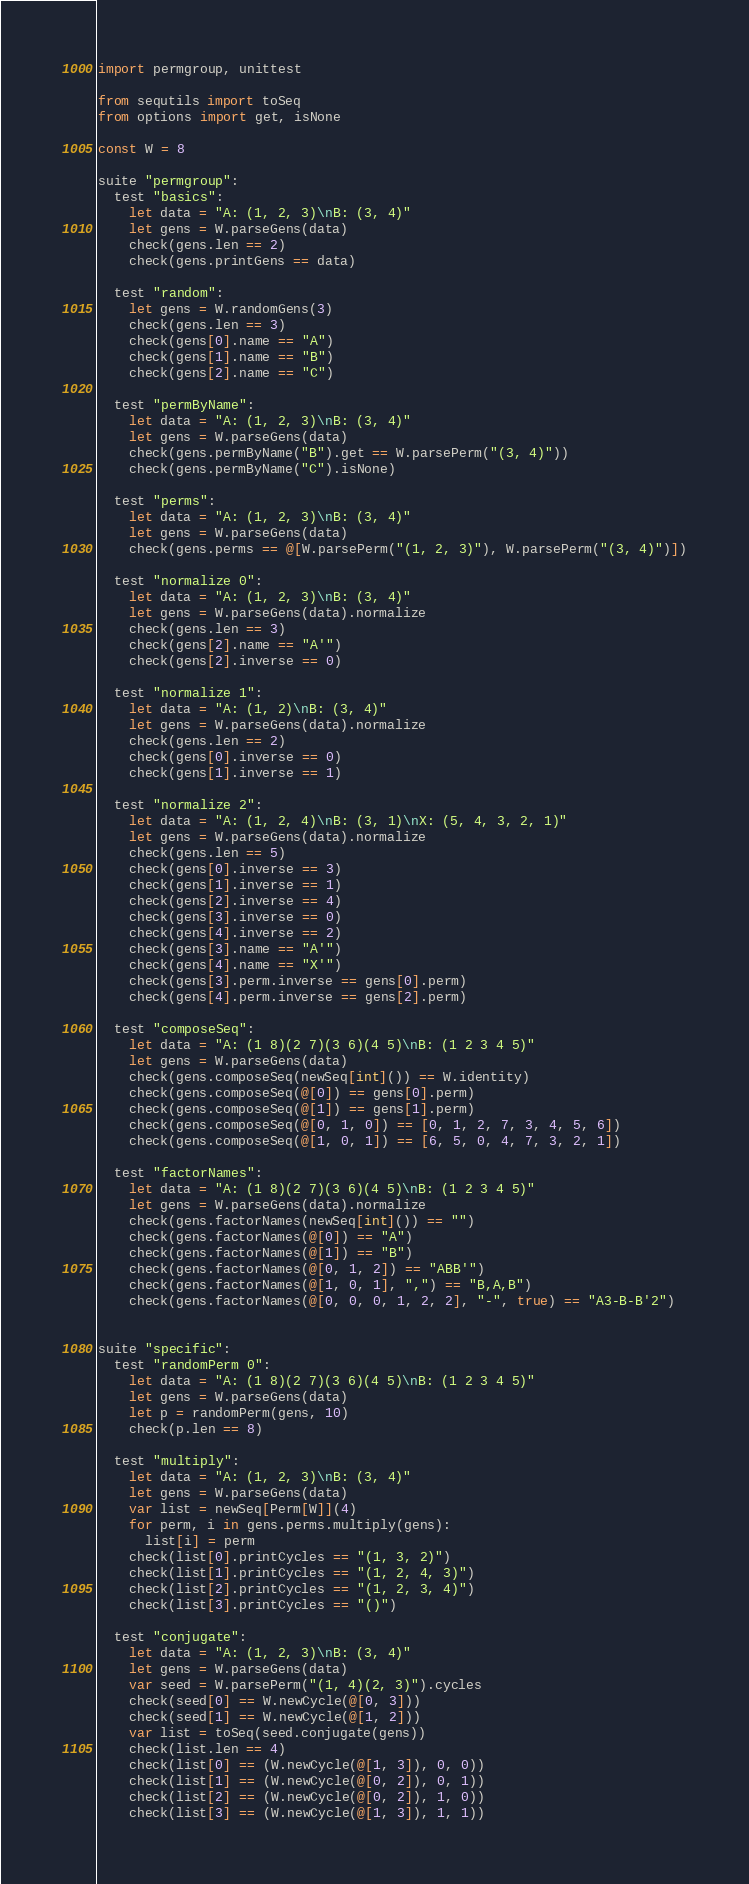<code> <loc_0><loc_0><loc_500><loc_500><_Nim_>import permgroup, unittest

from sequtils import toSeq
from options import get, isNone

const W = 8

suite "permgroup":
  test "basics":
    let data = "A: (1, 2, 3)\nB: (3, 4)"
    let gens = W.parseGens(data)
    check(gens.len == 2)
    check(gens.printGens == data)

  test "random":
    let gens = W.randomGens(3)
    check(gens.len == 3)
    check(gens[0].name == "A")
    check(gens[1].name == "B")
    check(gens[2].name == "C")

  test "permByName":
    let data = "A: (1, 2, 3)\nB: (3, 4)"
    let gens = W.parseGens(data)
    check(gens.permByName("B").get == W.parsePerm("(3, 4)"))
    check(gens.permByName("C").isNone)

  test "perms":
    let data = "A: (1, 2, 3)\nB: (3, 4)"
    let gens = W.parseGens(data)
    check(gens.perms == @[W.parsePerm("(1, 2, 3)"), W.parsePerm("(3, 4)")])

  test "normalize 0":
    let data = "A: (1, 2, 3)\nB: (3, 4)"
    let gens = W.parseGens(data).normalize
    check(gens.len == 3)
    check(gens[2].name == "A'")
    check(gens[2].inverse == 0)

  test "normalize 1":
    let data = "A: (1, 2)\nB: (3, 4)"
    let gens = W.parseGens(data).normalize
    check(gens.len == 2)
    check(gens[0].inverse == 0)
    check(gens[1].inverse == 1)

  test "normalize 2":
    let data = "A: (1, 2, 4)\nB: (3, 1)\nX: (5, 4, 3, 2, 1)"
    let gens = W.parseGens(data).normalize
    check(gens.len == 5)
    check(gens[0].inverse == 3)
    check(gens[1].inverse == 1)
    check(gens[2].inverse == 4)
    check(gens[3].inverse == 0)
    check(gens[4].inverse == 2)
    check(gens[3].name == "A'")
    check(gens[4].name == "X'")
    check(gens[3].perm.inverse == gens[0].perm)
    check(gens[4].perm.inverse == gens[2].perm)

  test "composeSeq":
    let data = "A: (1 8)(2 7)(3 6)(4 5)\nB: (1 2 3 4 5)"
    let gens = W.parseGens(data)
    check(gens.composeSeq(newSeq[int]()) == W.identity)
    check(gens.composeSeq(@[0]) == gens[0].perm)
    check(gens.composeSeq(@[1]) == gens[1].perm)
    check(gens.composeSeq(@[0, 1, 0]) == [0, 1, 2, 7, 3, 4, 5, 6])
    check(gens.composeSeq(@[1, 0, 1]) == [6, 5, 0, 4, 7, 3, 2, 1])

  test "factorNames":
    let data = "A: (1 8)(2 7)(3 6)(4 5)\nB: (1 2 3 4 5)"
    let gens = W.parseGens(data).normalize
    check(gens.factorNames(newSeq[int]()) == "")
    check(gens.factorNames(@[0]) == "A")
    check(gens.factorNames(@[1]) == "B")
    check(gens.factorNames(@[0, 1, 2]) == "ABB'")
    check(gens.factorNames(@[1, 0, 1], ",") == "B,A,B")
    check(gens.factorNames(@[0, 0, 0, 1, 2, 2], "-", true) == "A3-B-B'2")


suite "specific":
  test "randomPerm 0":
    let data = "A: (1 8)(2 7)(3 6)(4 5)\nB: (1 2 3 4 5)"
    let gens = W.parseGens(data)
    let p = randomPerm(gens, 10)
    check(p.len == 8)

  test "multiply":
    let data = "A: (1, 2, 3)\nB: (3, 4)"
    let gens = W.parseGens(data)
    var list = newSeq[Perm[W]](4)
    for perm, i in gens.perms.multiply(gens):
      list[i] = perm
    check(list[0].printCycles == "(1, 3, 2)")
    check(list[1].printCycles == "(1, 2, 4, 3)")
    check(list[2].printCycles == "(1, 2, 3, 4)")
    check(list[3].printCycles == "()")

  test "conjugate":
    let data = "A: (1, 2, 3)\nB: (3, 4)"
    let gens = W.parseGens(data)
    var seed = W.parsePerm("(1, 4)(2, 3)").cycles
    check(seed[0] == W.newCycle(@[0, 3]))
    check(seed[1] == W.newCycle(@[1, 2]))
    var list = toSeq(seed.conjugate(gens))
    check(list.len == 4)
    check(list[0] == (W.newCycle(@[1, 3]), 0, 0))
    check(list[1] == (W.newCycle(@[0, 2]), 0, 1))
    check(list[2] == (W.newCycle(@[0, 2]), 1, 0))
    check(list[3] == (W.newCycle(@[1, 3]), 1, 1))
</code> 